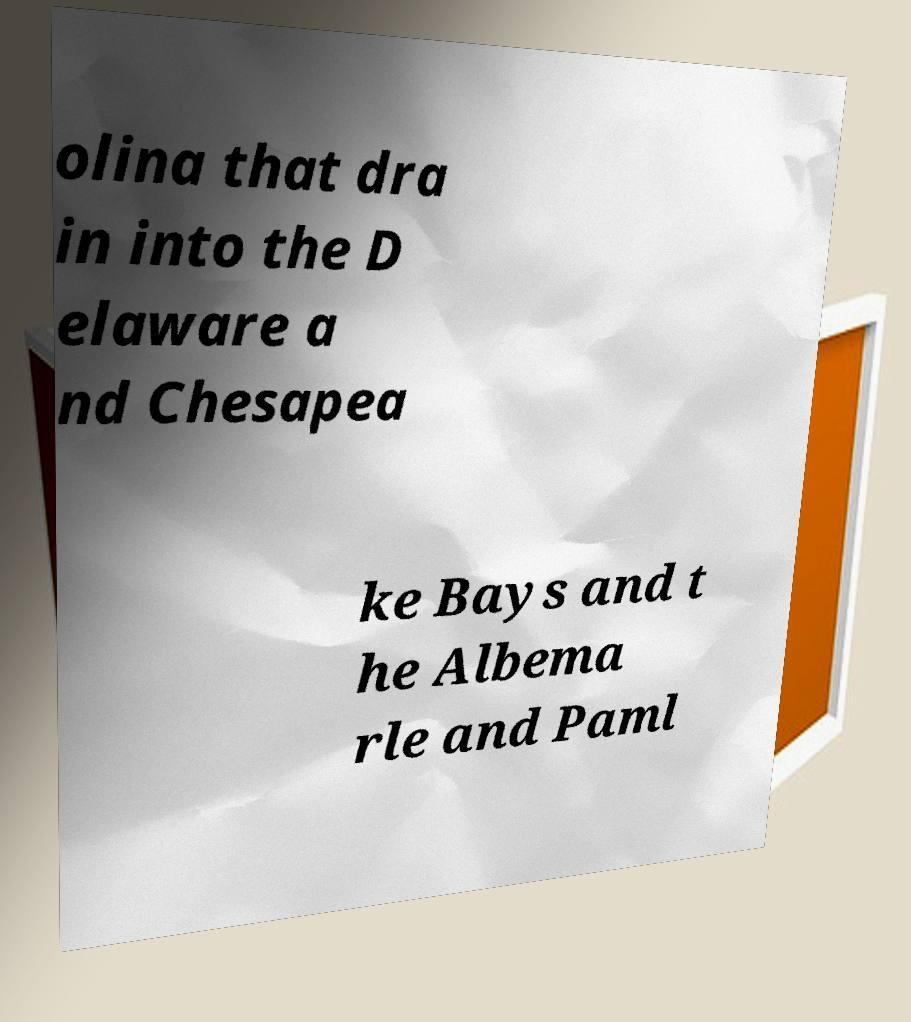Please read and relay the text visible in this image. What does it say? olina that dra in into the D elaware a nd Chesapea ke Bays and t he Albema rle and Paml 